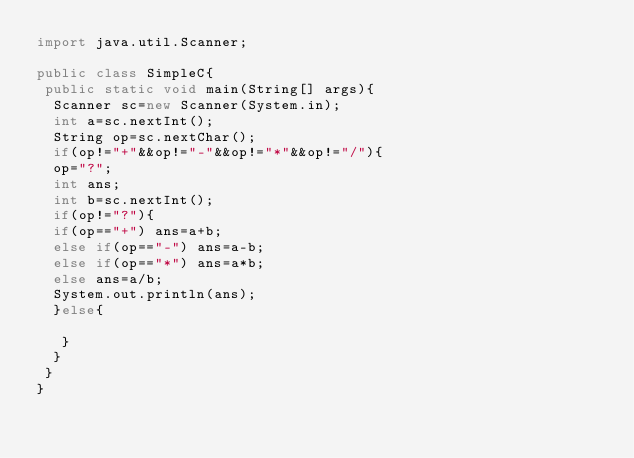Convert code to text. <code><loc_0><loc_0><loc_500><loc_500><_Java_>import java.util.Scanner;

public class SimpleC{
 public static void main(String[] args){
  Scanner sc=new Scanner(System.in);
  int a=sc.nextInt();
  String op=sc.nextChar();
  if(op!="+"&&op!="-"&&op!="*"&&op!="/"){
  op="?";
  int ans;
  int b=sc.nextInt();
  if(op!="?"){
  if(op=="+") ans=a+b;
  else if(op=="-") ans=a-b;
  else if(op=="*") ans=a*b;
  else ans=a/b;
  System.out.println(ans);
  }else{
   
   }
  }
 }
}
 
  </code> 